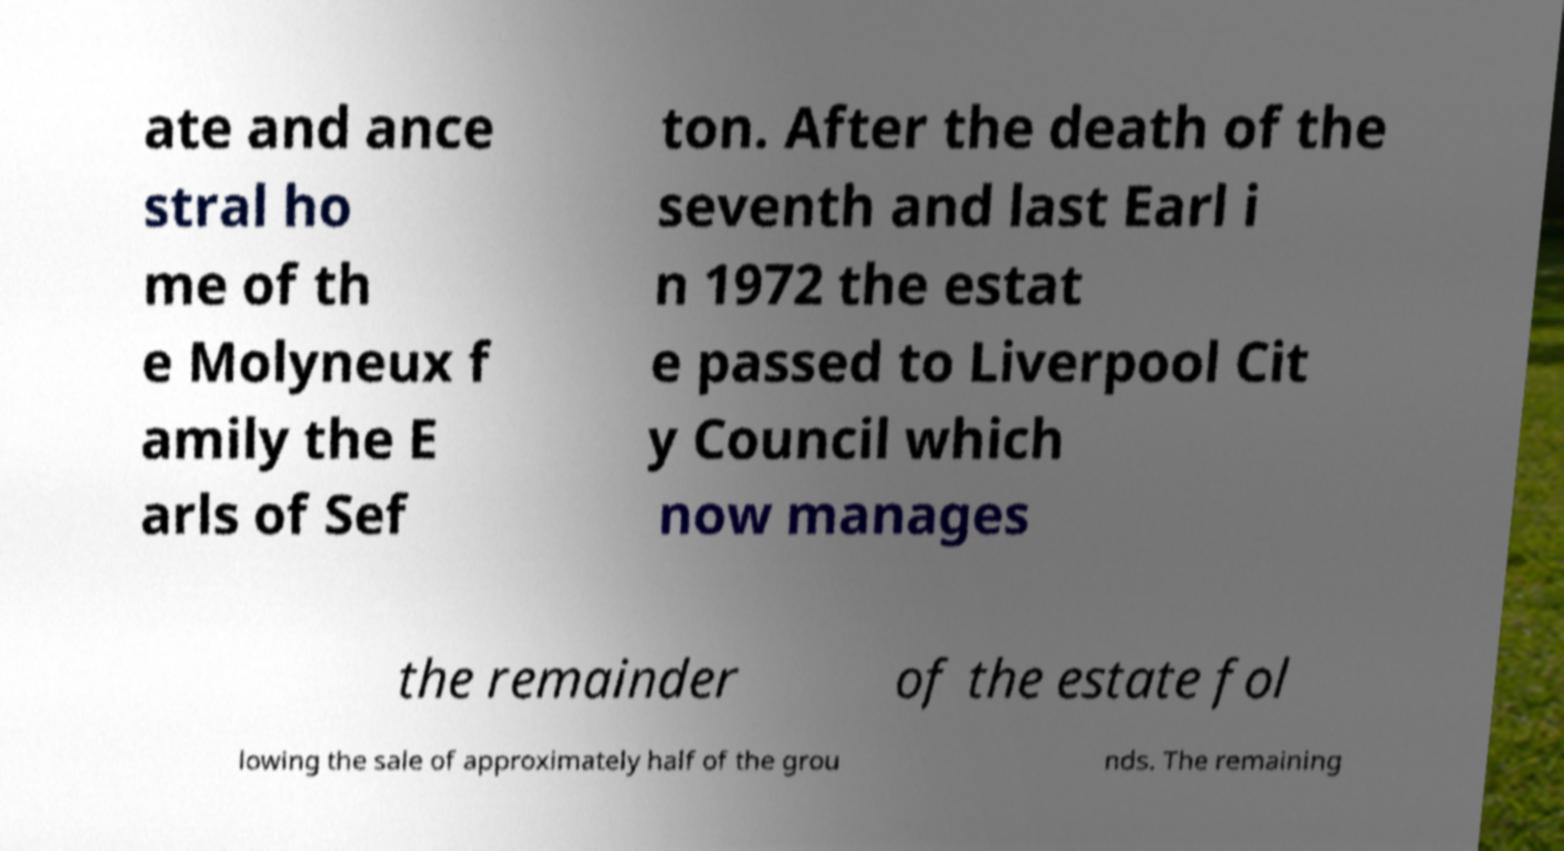What messages or text are displayed in this image? I need them in a readable, typed format. ate and ance stral ho me of th e Molyneux f amily the E arls of Sef ton. After the death of the seventh and last Earl i n 1972 the estat e passed to Liverpool Cit y Council which now manages the remainder of the estate fol lowing the sale of approximately half of the grou nds. The remaining 